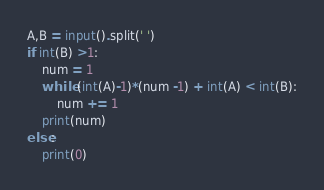Convert code to text. <code><loc_0><loc_0><loc_500><loc_500><_Python_>A,B = input().split(' ')
if int(B) >1:
    num = 1
    while (int(A)-1)*(num -1) + int(A) < int(B):
        num += 1
    print(num)
else:
    print(0)
</code> 